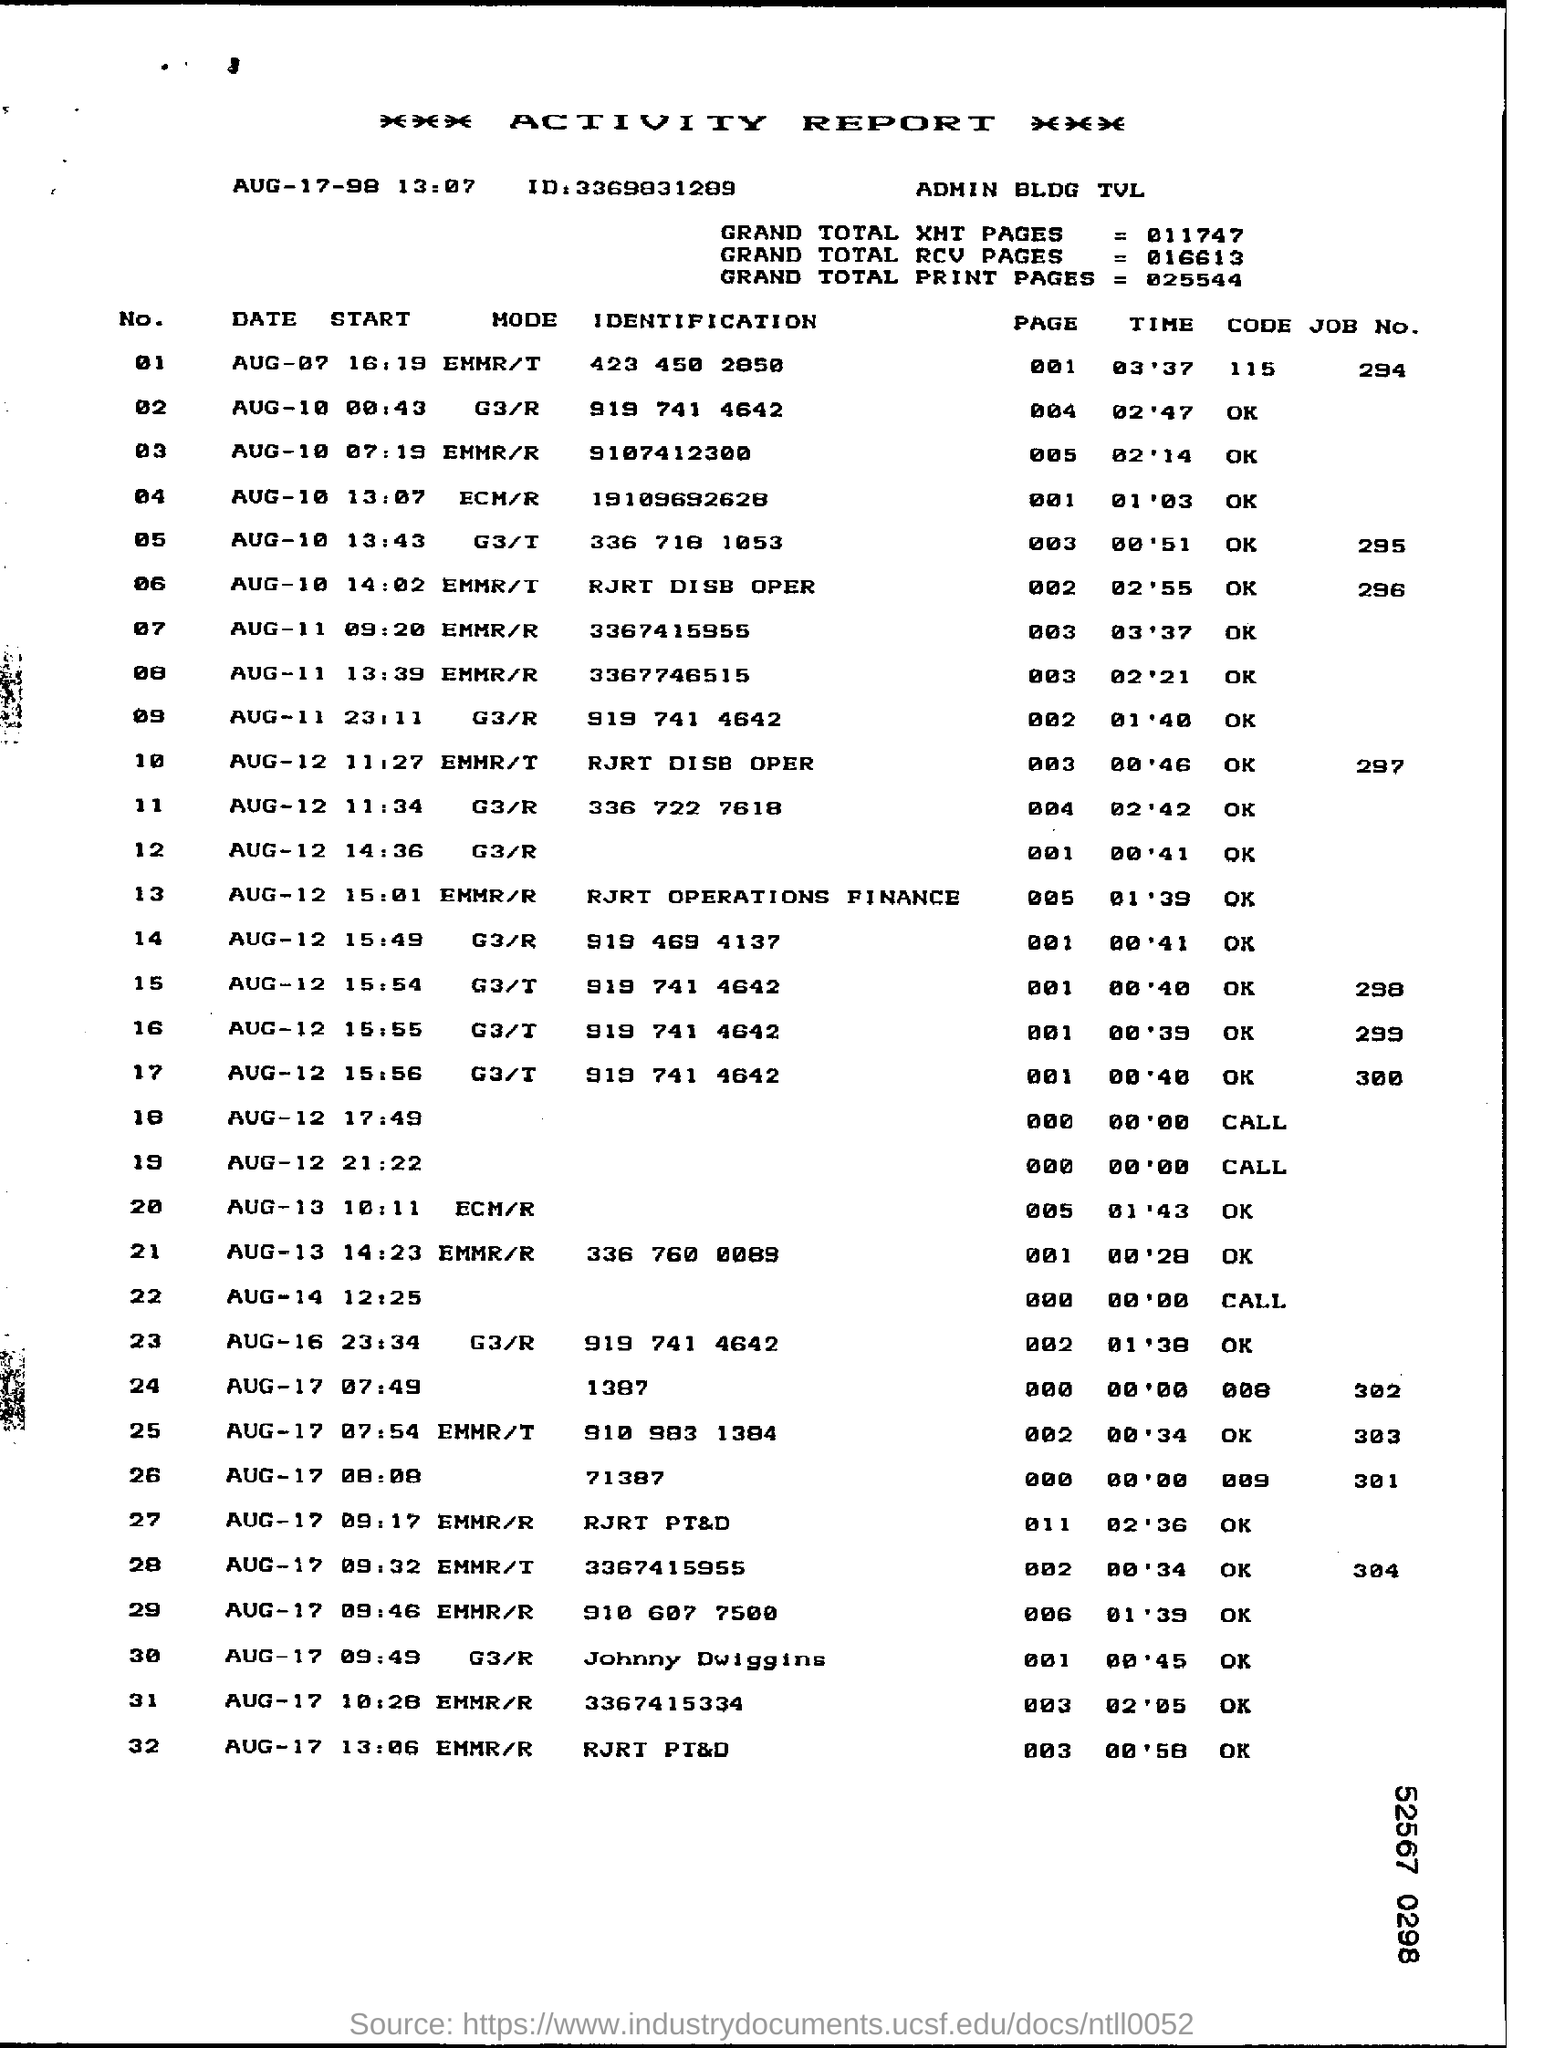What is the ID mentioned under 'Activity Report' heading?
Make the answer very short. ID:3369831289. How much is the 'Grand Total RCV Pages' ?
Give a very brief answer. 016613. What is the 'Mode' given against No '01' ?
Provide a short and direct response. EMMR/T. Which 'DATE' is given against No '10' ?
Make the answer very short. Aug-12. 